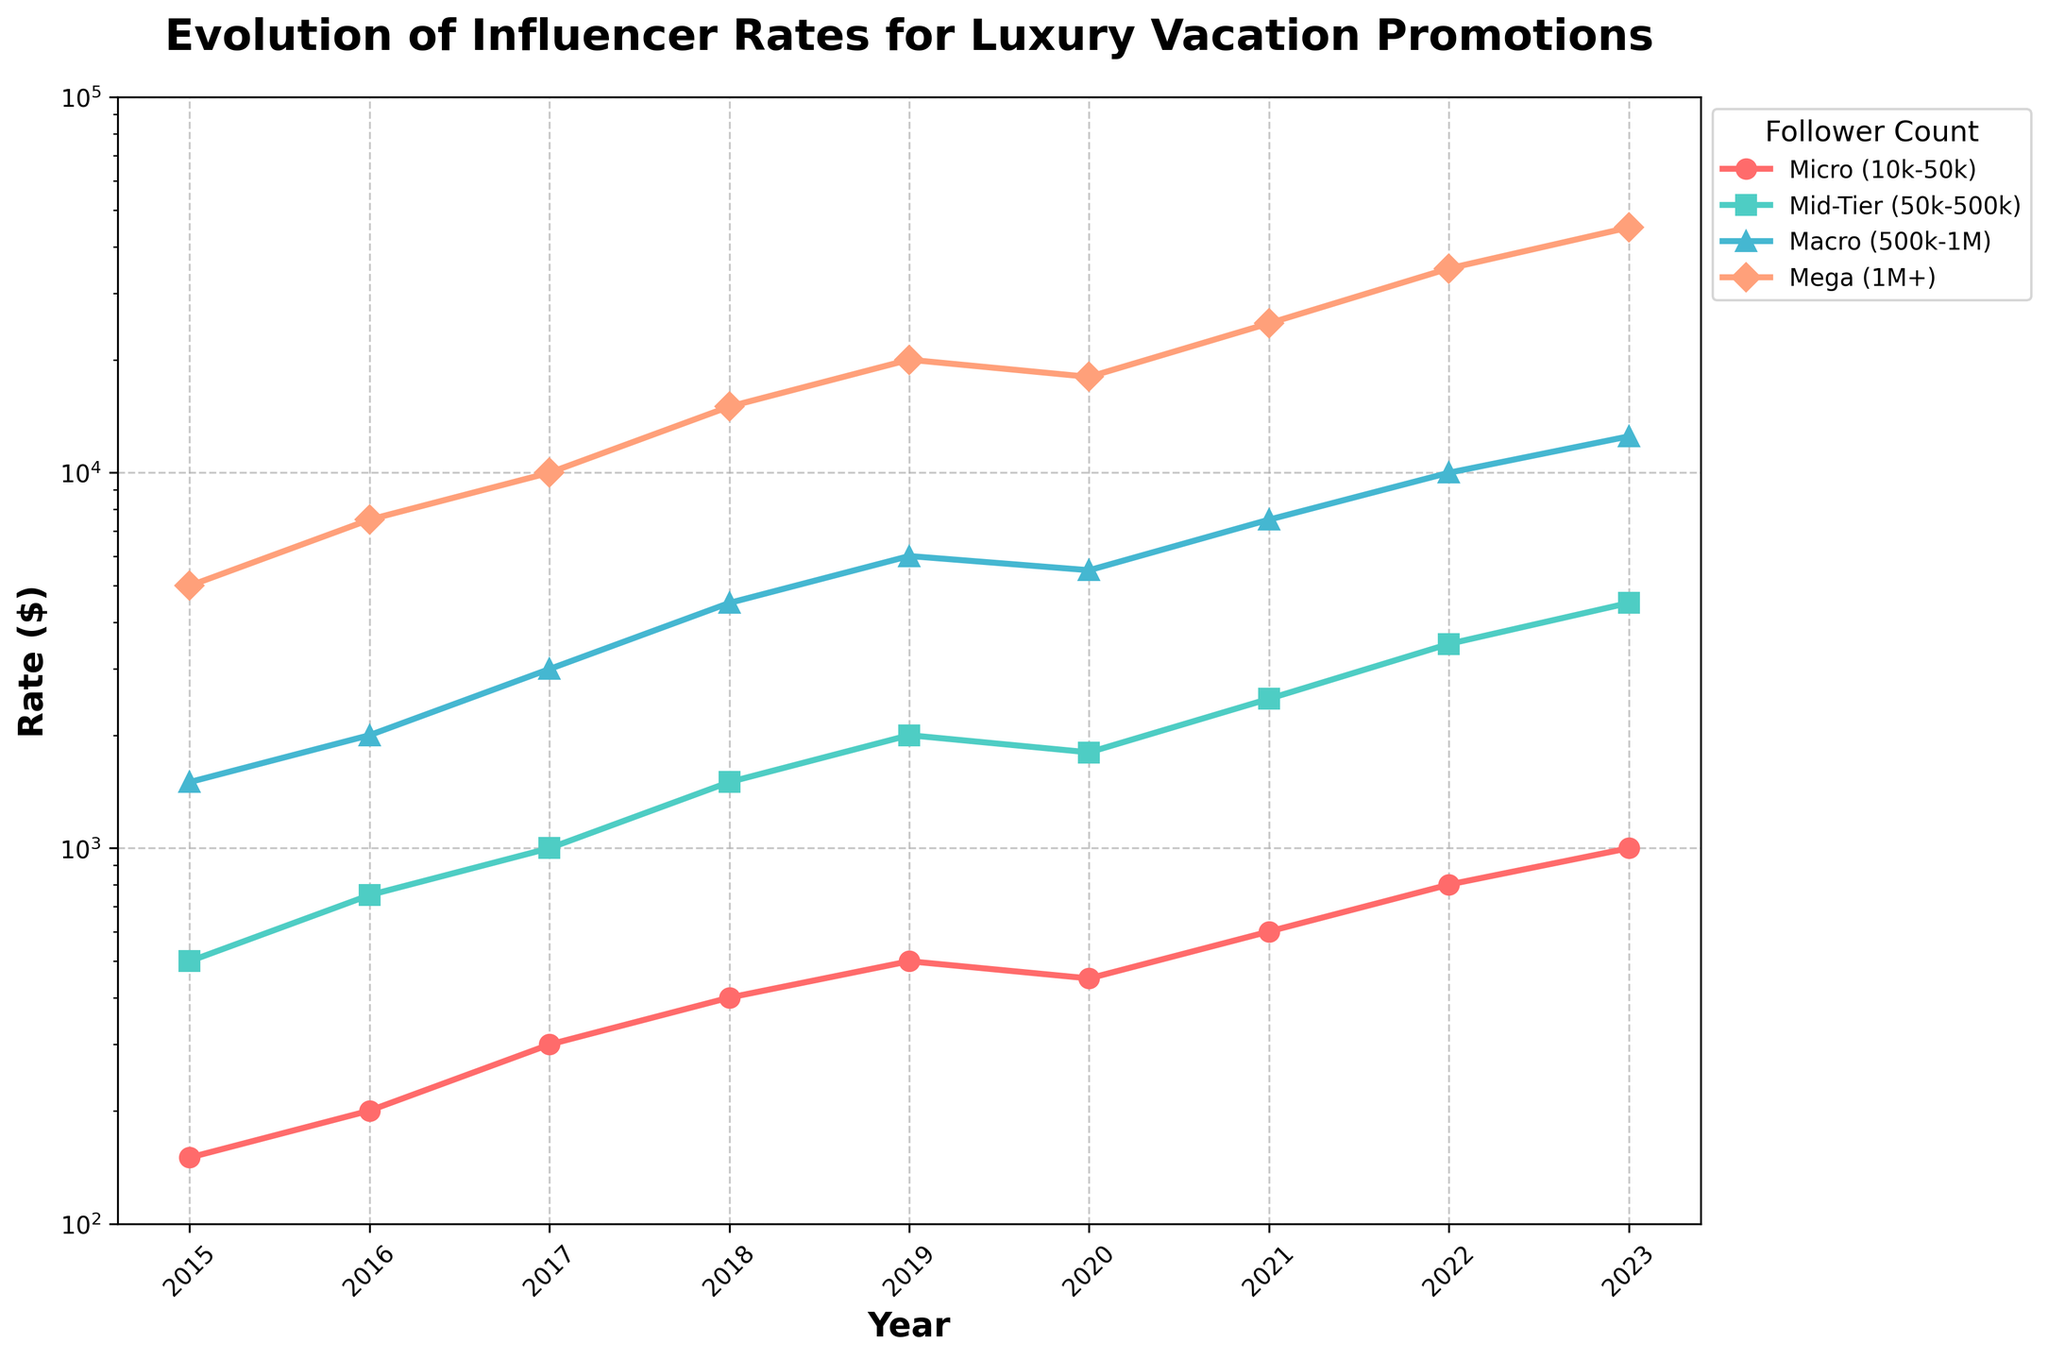What was the rate for Mid-Tier influencers in 2020? Looking at the line for Mid-Tier influencers, find the point corresponding to the year 2020. The rate is displayed next to that point.
Answer: 1800 Which year did the Mega influencers see the largest increase in their rates compared to the previous year? Compare the increases year by year in the Mega influencer data line by calculating each year's rate minus the previous year's rate. The largest increase is from 2022 to 2023 (45000 - 35000 = 10000).
Answer: 2023 What is the overall trend for Micro influencers from 2015 to 2023? Observing the line for Micro influencers from 2015 to 2023, the rates show a steady increase over the years.
Answer: Steady increase Which influencer category saw a rate decrease in 2020? Check each line for a decrease in height at 2020. Only the Macro and Mega influencer lines decrease from 2019 to 2020.
Answer: Macro, Mega How much more were Mega influencers paid in 2023 compared to Micro influencers in the same year? Find the rates for Mega (45000) and Micro (1000) influencers in 2023. Subtract the Micro rate from the Mega rate: 45000 - 1000 = 44000.
Answer: 44000 What color line represents the Mid-Tier influencers? Refer to the color legend to find the line color associated with Mid-Tier influencers. The Mid-Tier line is green in the legend.
Answer: Green Which year did Micro influencers surpass the rate of $500? Locate the points on the Micro influencer line and find the first year where the rate exceeds $500. It is 2019.
Answer: 2019 What is the ratio of Mega influencer rates to Mid-Tier influencer rates in 2023? Divide the Mega influencer rate in 2023 (45000) by the Mid-Tier influencer rate in 2023 (4500): 45000 / 4500 = 10.
Answer: 10 How much did the Macro influencer rate increase from 2018 to 2022? Subtract the 2018 rate for Macro influencers (4500) from the 2022 rate (10000): 10000 - 4500 = 5500.
Answer: 5500 Which influencer category had the smallest overall percentage increase from 2015 to 2023? Calculate the percentage increase for each category by (Rate in 2023 - Rate in 2015) / Rate in 2015 * 100% and compare. Micro: ((1000-150)/150)*100 = 566%, Mid-Tier: ((4500-500)/500)*100 = 800%, Macro: ((12500-1500)/1500)*100 = 733%, Mega: ((45000-5000)/5000)*100 = 800%. The category with the smallest increase is Macro.
Answer: Macro 